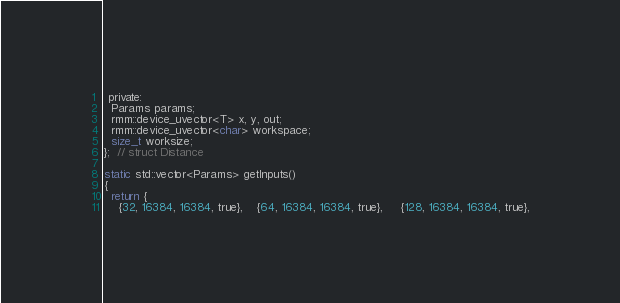<code> <loc_0><loc_0><loc_500><loc_500><_Cuda_> private:
  Params params;
  rmm::device_uvector<T> x, y, out;
  rmm::device_uvector<char> workspace;
  size_t worksize;
};  // struct Distance

static std::vector<Params> getInputs()
{
  return {
    {32, 16384, 16384, true},    {64, 16384, 16384, true},     {128, 16384, 16384, true},</code> 